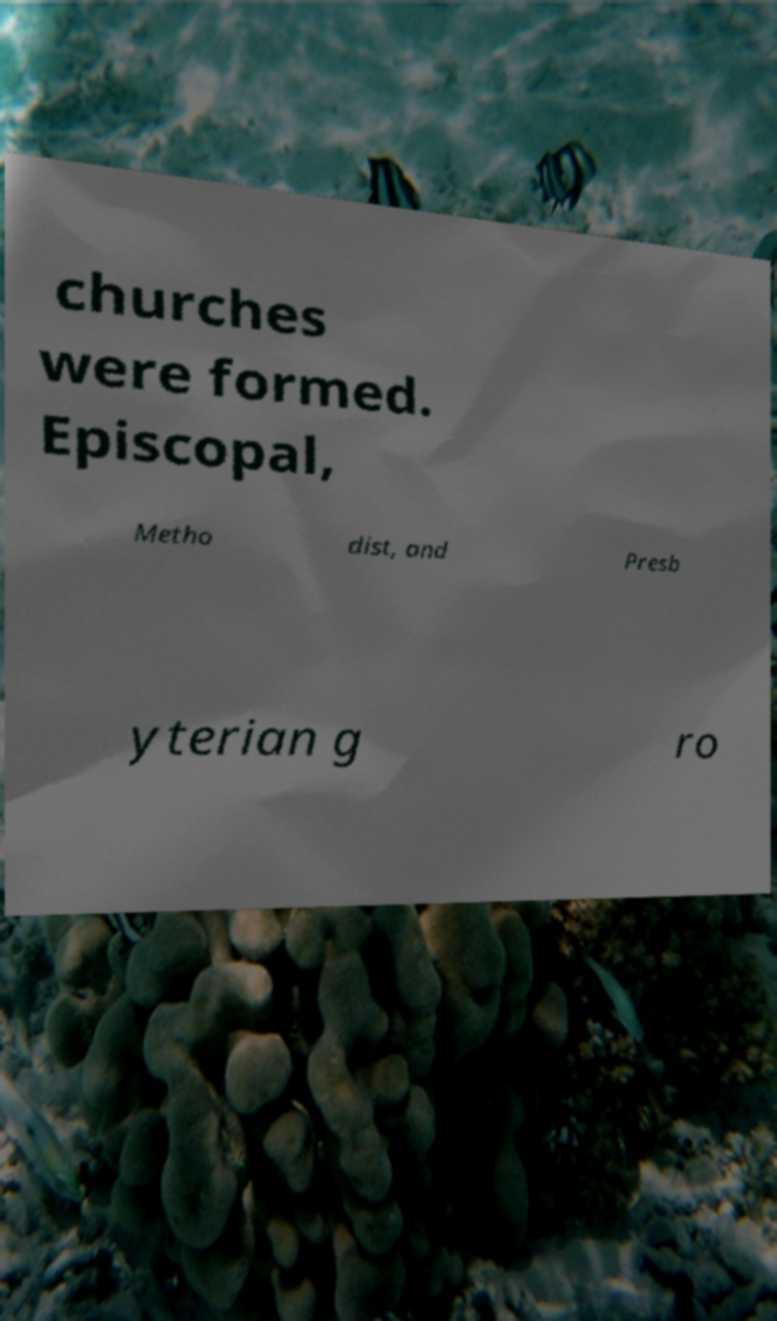I need the written content from this picture converted into text. Can you do that? churches were formed. Episcopal, Metho dist, and Presb yterian g ro 